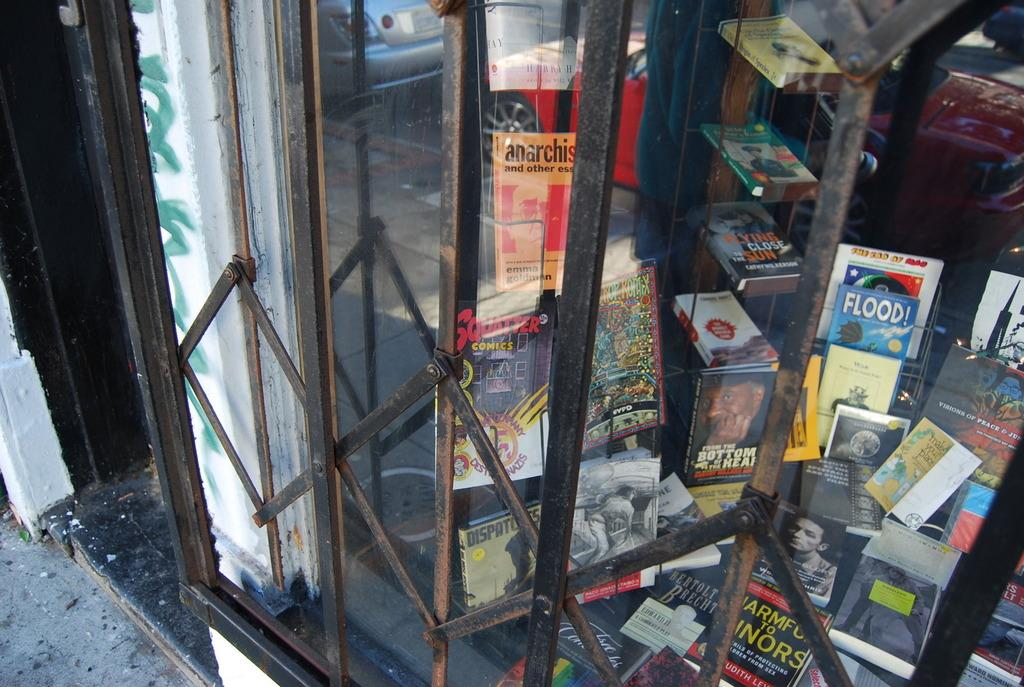What type of material is present in the image? There are metal rods and glass in the image. What else can be seen in the image besides the metal rods and glass? There are books in the image. What can be observed in the reflection in the image? In the reflection, there are cars visible. Where is the bubble located in the image? There is no bubble present in the image. What type of science is being conducted on the desk in the image? There is no desk or science activity present in the image. 